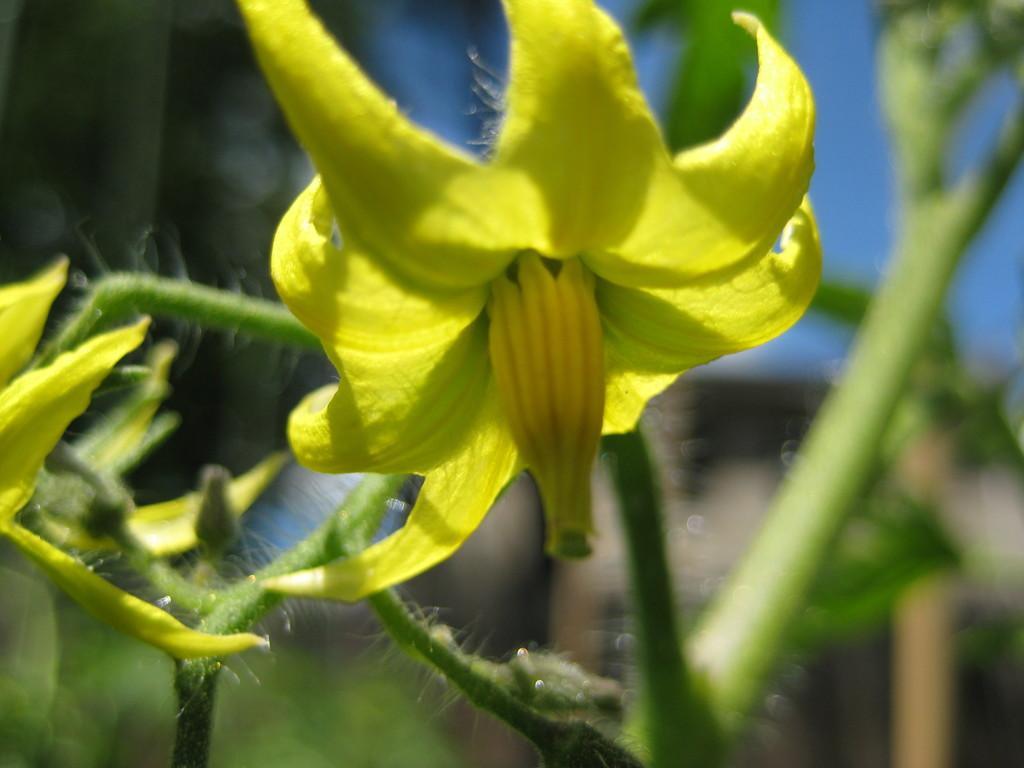In one or two sentences, can you explain what this image depicts? In this picture we can see flowers and in the background we can see leaves, sky and it is blurry. 